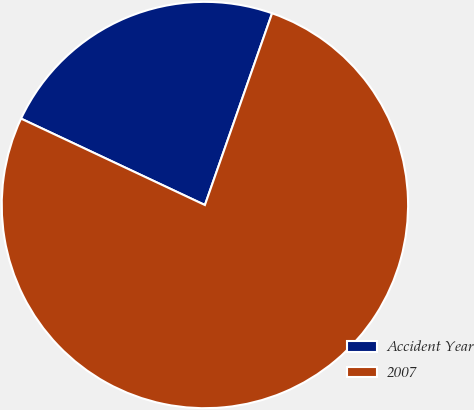<chart> <loc_0><loc_0><loc_500><loc_500><pie_chart><fcel>Accident Year<fcel>2007<nl><fcel>23.37%<fcel>76.63%<nl></chart> 